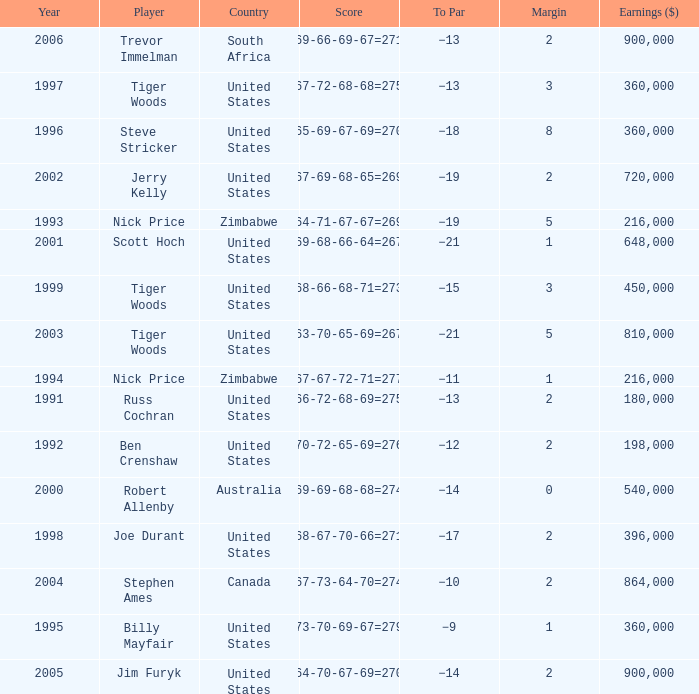What is canada's margin? 2.0. 